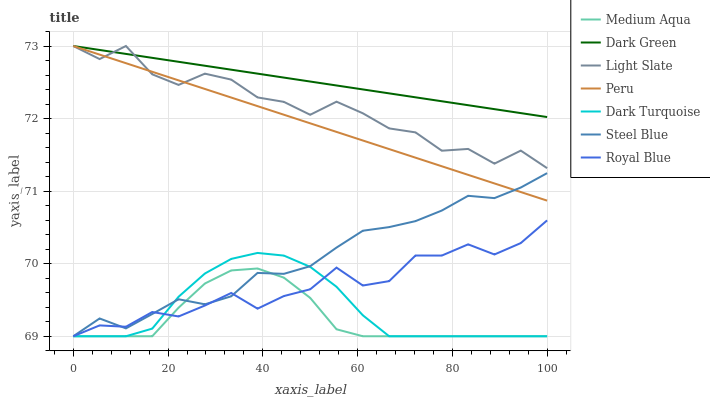Does Medium Aqua have the minimum area under the curve?
Answer yes or no. Yes. Does Dark Green have the maximum area under the curve?
Answer yes or no. Yes. Does Dark Turquoise have the minimum area under the curve?
Answer yes or no. No. Does Dark Turquoise have the maximum area under the curve?
Answer yes or no. No. Is Dark Green the smoothest?
Answer yes or no. Yes. Is Light Slate the roughest?
Answer yes or no. Yes. Is Dark Turquoise the smoothest?
Answer yes or no. No. Is Dark Turquoise the roughest?
Answer yes or no. No. Does Dark Turquoise have the lowest value?
Answer yes or no. Yes. Does Peru have the lowest value?
Answer yes or no. No. Does Dark Green have the highest value?
Answer yes or no. Yes. Does Dark Turquoise have the highest value?
Answer yes or no. No. Is Royal Blue less than Peru?
Answer yes or no. Yes. Is Dark Green greater than Medium Aqua?
Answer yes or no. Yes. Does Steel Blue intersect Medium Aqua?
Answer yes or no. Yes. Is Steel Blue less than Medium Aqua?
Answer yes or no. No. Is Steel Blue greater than Medium Aqua?
Answer yes or no. No. Does Royal Blue intersect Peru?
Answer yes or no. No. 